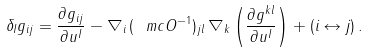<formula> <loc_0><loc_0><loc_500><loc_500>\delta _ { I } g _ { i j } = \frac { \partial g _ { i j } } { \partial u ^ { I } } - \nabla _ { i } \, ( \ m c O ^ { - 1 } ) _ { j l } \, \nabla _ { k } \left ( \frac { \partial g ^ { k l } } { \partial u ^ { I } } \right ) + ( i \leftrightarrow j ) \, .</formula> 